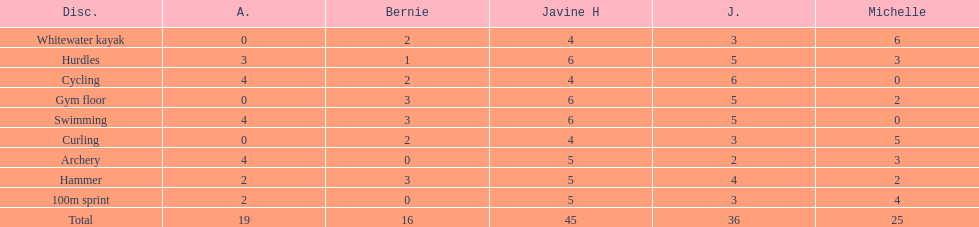Who scored the least on whitewater kayak? Amanda. 